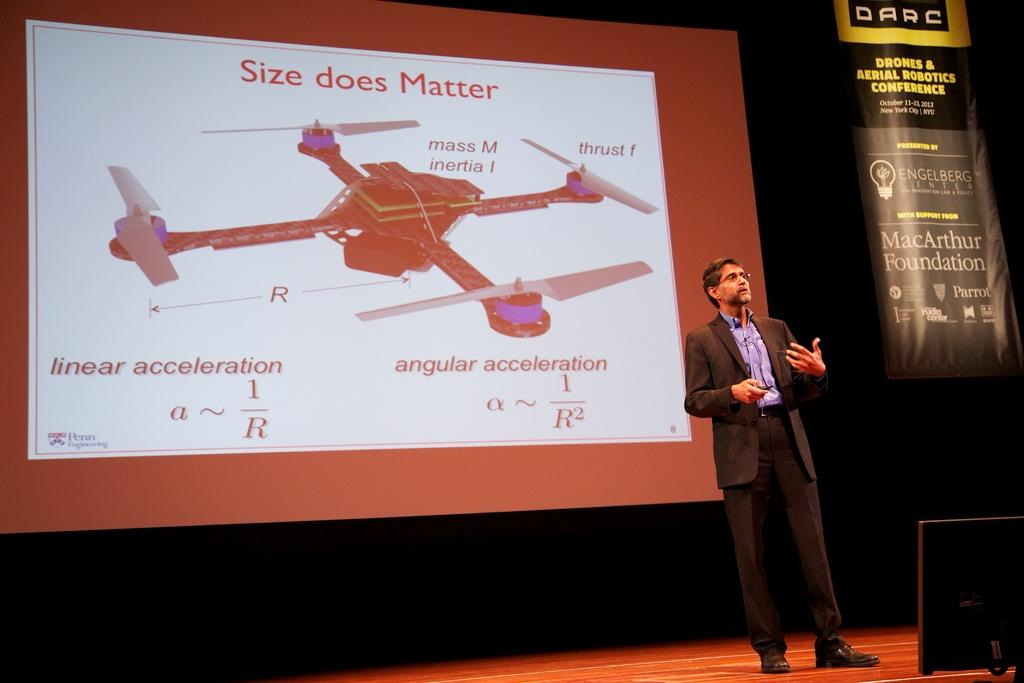<image>
Provide a brief description of the given image. Presentation of size does not matter on a plane with a Darc logo from MacArthur Foundation on the right side. 